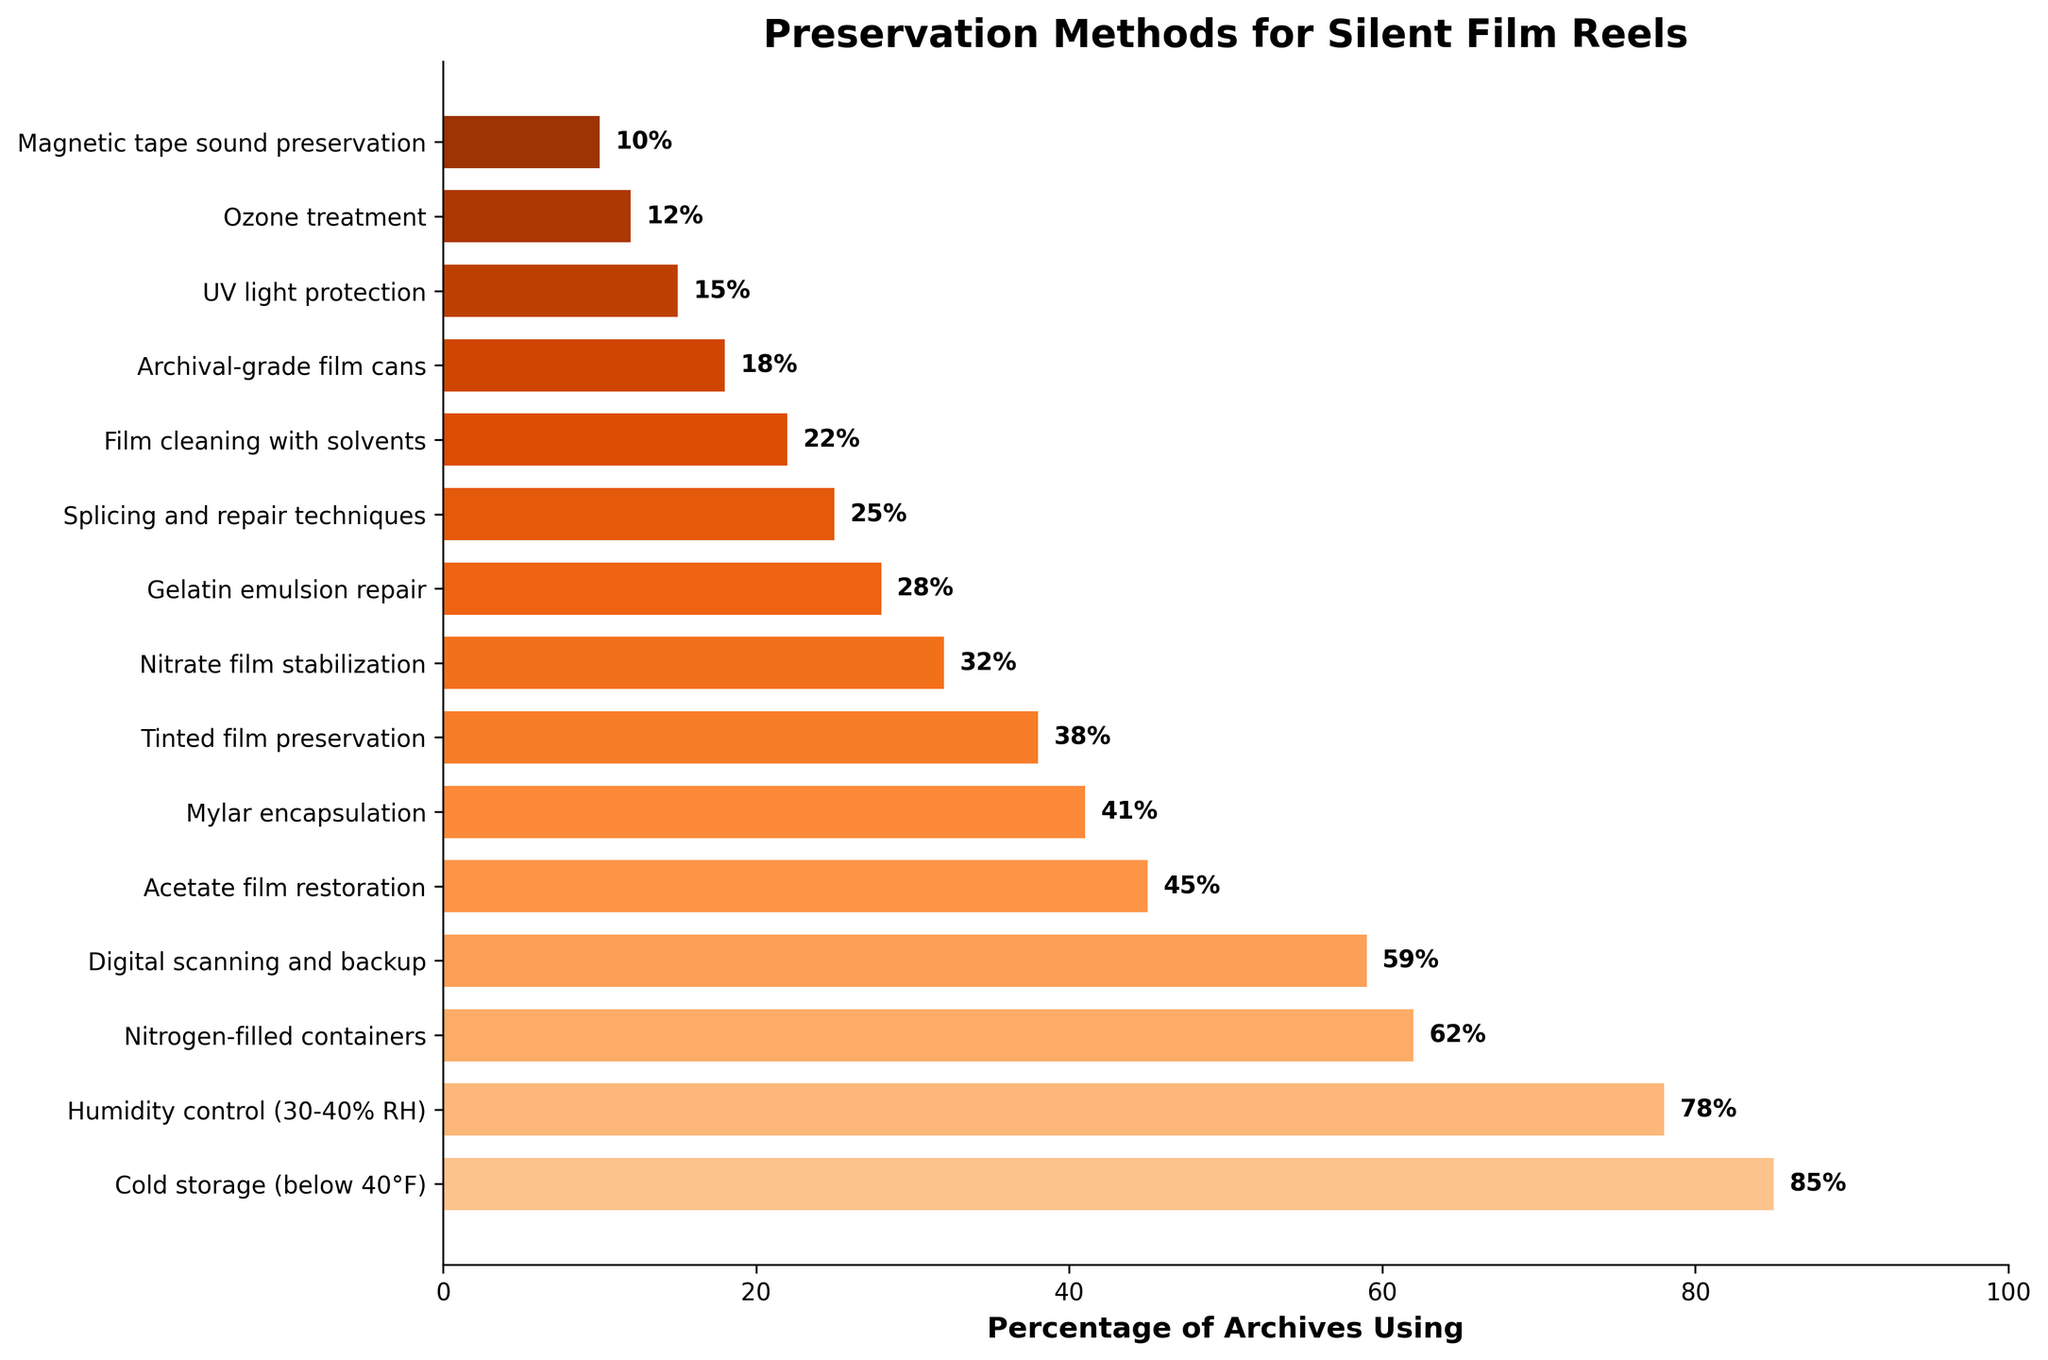Which preservation method is used by the highest percentage of archives? The bar representing "Cold storage (below 40°F)" reaches the furthest to the right on the x-axis, indicating it’s used by the highest percentage of archives.
Answer: Cold storage (below 40°F) What percentage of archives use digital scanning and backup? The bar for "Digital scanning and backup" has a label next to it indicating 59%.
Answer: 59% Which method is less commonly used: nitrogen-filled containers or acetate film restoration? Comparing the lengths of the bars, the bar for "Nitrogen-filled containers" is longer than the one for "Acetate film restoration", indicating a higher percentage for nitrogen-filled containers.
Answer: Acetate film restoration What is the combined percentage of archives using cold storage and humidity control? The percentage for cold storage is 85% and for humidity control is 78%. Adding them together gives 85 + 78 = 163%.
Answer: 163% Which two methods are the least commonly used? The shortest bars on the chart correspond to "Ozone treatment" and "Magnetic tape sound preservation," indicating they are used by the lowest percentages of archives.
Answer: Ozone treatment and Magnetic tape sound preservation How much higher is the usage of digital scanning and backup compared to Mylar encapsulation? The percentage for digital scanning and backup is 59% and for Mylar encapsulation is 41%. Subtracting them gives 59 - 41 = 18%.
Answer: 18% What is the percentage difference between the most and least used preservation methods? The most used method is cold storage at 85%, and the least used is magnetic tape sound preservation at 10%. The difference is 85 - 10 = 75%.
Answer: 75% What is the average usage percentage for the top three most commonly used methods? The top three methods are Cold storage (85%), Humidity control (78%), and Nitrogen-filled containers (62%). The average is (85 + 78 + 62) / 3 = 75%.
Answer: 75% Which methods have usage percentages above 60%? The bars for "Cold storage (below 40°F)," "Humidity control (30-40% RH)," and "Nitrogen-filled containers" each have a percentage above 60%.
Answer: Cold storage, Humidity control, and Nitrogen-filled containers 